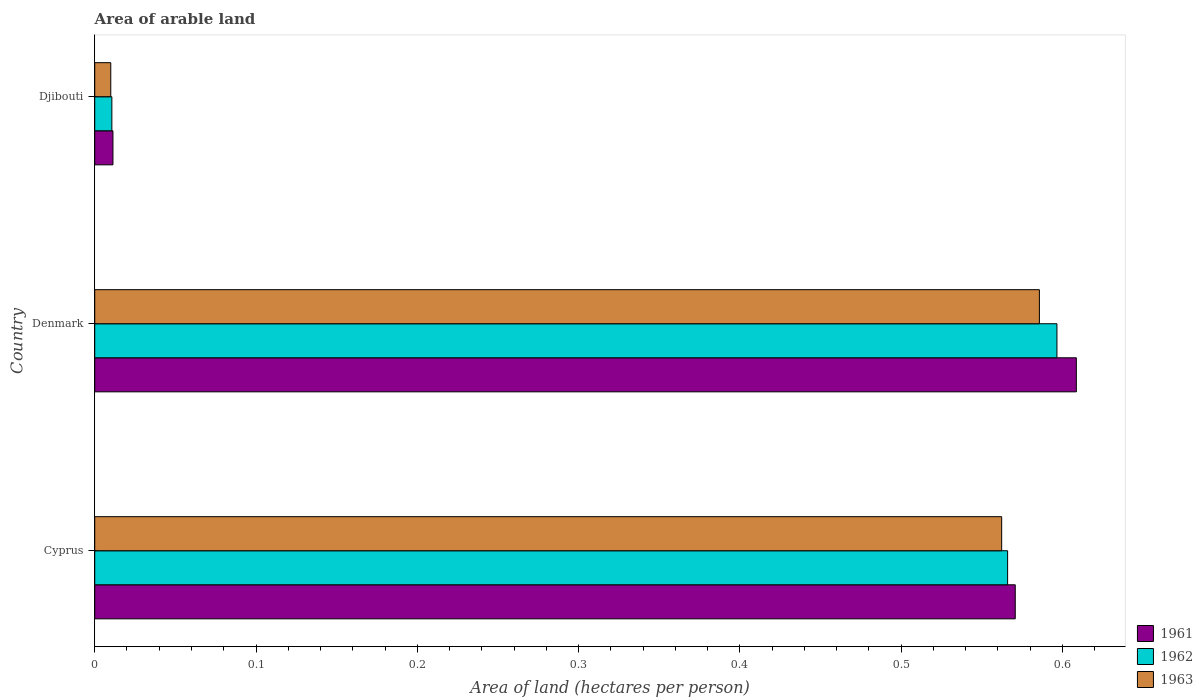How many groups of bars are there?
Provide a short and direct response. 3. Are the number of bars per tick equal to the number of legend labels?
Offer a very short reply. Yes. How many bars are there on the 2nd tick from the bottom?
Make the answer very short. 3. What is the label of the 2nd group of bars from the top?
Keep it short and to the point. Denmark. In how many cases, is the number of bars for a given country not equal to the number of legend labels?
Offer a very short reply. 0. What is the total arable land in 1961 in Denmark?
Your answer should be very brief. 0.61. Across all countries, what is the maximum total arable land in 1962?
Offer a terse response. 0.6. Across all countries, what is the minimum total arable land in 1963?
Your response must be concise. 0.01. In which country was the total arable land in 1963 minimum?
Make the answer very short. Djibouti. What is the total total arable land in 1962 in the graph?
Your answer should be compact. 1.17. What is the difference between the total arable land in 1961 in Denmark and that in Djibouti?
Make the answer very short. 0.6. What is the difference between the total arable land in 1962 in Denmark and the total arable land in 1961 in Cyprus?
Offer a very short reply. 0.03. What is the average total arable land in 1961 per country?
Your answer should be very brief. 0.4. What is the difference between the total arable land in 1961 and total arable land in 1962 in Denmark?
Provide a short and direct response. 0.01. What is the ratio of the total arable land in 1962 in Cyprus to that in Djibouti?
Your answer should be compact. 53.32. Is the difference between the total arable land in 1961 in Cyprus and Denmark greater than the difference between the total arable land in 1962 in Cyprus and Denmark?
Give a very brief answer. No. What is the difference between the highest and the second highest total arable land in 1963?
Your response must be concise. 0.02. What is the difference between the highest and the lowest total arable land in 1963?
Offer a very short reply. 0.58. Is the sum of the total arable land in 1963 in Cyprus and Djibouti greater than the maximum total arable land in 1961 across all countries?
Provide a short and direct response. No. Is it the case that in every country, the sum of the total arable land in 1962 and total arable land in 1963 is greater than the total arable land in 1961?
Offer a terse response. Yes. Are all the bars in the graph horizontal?
Provide a short and direct response. Yes. Does the graph contain any zero values?
Give a very brief answer. No. Does the graph contain grids?
Make the answer very short. No. Where does the legend appear in the graph?
Make the answer very short. Bottom right. How many legend labels are there?
Offer a terse response. 3. How are the legend labels stacked?
Provide a succinct answer. Vertical. What is the title of the graph?
Provide a succinct answer. Area of arable land. What is the label or title of the X-axis?
Offer a terse response. Area of land (hectares per person). What is the Area of land (hectares per person) of 1961 in Cyprus?
Ensure brevity in your answer.  0.57. What is the Area of land (hectares per person) in 1962 in Cyprus?
Offer a terse response. 0.57. What is the Area of land (hectares per person) of 1963 in Cyprus?
Ensure brevity in your answer.  0.56. What is the Area of land (hectares per person) of 1961 in Denmark?
Make the answer very short. 0.61. What is the Area of land (hectares per person) in 1962 in Denmark?
Offer a very short reply. 0.6. What is the Area of land (hectares per person) in 1963 in Denmark?
Offer a terse response. 0.59. What is the Area of land (hectares per person) of 1961 in Djibouti?
Ensure brevity in your answer.  0.01. What is the Area of land (hectares per person) of 1962 in Djibouti?
Make the answer very short. 0.01. What is the Area of land (hectares per person) of 1963 in Djibouti?
Make the answer very short. 0.01. Across all countries, what is the maximum Area of land (hectares per person) in 1961?
Make the answer very short. 0.61. Across all countries, what is the maximum Area of land (hectares per person) in 1962?
Your answer should be compact. 0.6. Across all countries, what is the maximum Area of land (hectares per person) of 1963?
Provide a short and direct response. 0.59. Across all countries, what is the minimum Area of land (hectares per person) in 1961?
Offer a very short reply. 0.01. Across all countries, what is the minimum Area of land (hectares per person) in 1962?
Keep it short and to the point. 0.01. Across all countries, what is the minimum Area of land (hectares per person) of 1963?
Your response must be concise. 0.01. What is the total Area of land (hectares per person) in 1961 in the graph?
Your answer should be compact. 1.19. What is the total Area of land (hectares per person) in 1962 in the graph?
Your response must be concise. 1.17. What is the total Area of land (hectares per person) in 1963 in the graph?
Your answer should be compact. 1.16. What is the difference between the Area of land (hectares per person) of 1961 in Cyprus and that in Denmark?
Make the answer very short. -0.04. What is the difference between the Area of land (hectares per person) of 1962 in Cyprus and that in Denmark?
Keep it short and to the point. -0.03. What is the difference between the Area of land (hectares per person) of 1963 in Cyprus and that in Denmark?
Give a very brief answer. -0.02. What is the difference between the Area of land (hectares per person) of 1961 in Cyprus and that in Djibouti?
Provide a succinct answer. 0.56. What is the difference between the Area of land (hectares per person) in 1962 in Cyprus and that in Djibouti?
Offer a terse response. 0.56. What is the difference between the Area of land (hectares per person) in 1963 in Cyprus and that in Djibouti?
Your response must be concise. 0.55. What is the difference between the Area of land (hectares per person) in 1961 in Denmark and that in Djibouti?
Provide a succinct answer. 0.6. What is the difference between the Area of land (hectares per person) of 1962 in Denmark and that in Djibouti?
Ensure brevity in your answer.  0.59. What is the difference between the Area of land (hectares per person) of 1963 in Denmark and that in Djibouti?
Provide a short and direct response. 0.58. What is the difference between the Area of land (hectares per person) in 1961 in Cyprus and the Area of land (hectares per person) in 1962 in Denmark?
Provide a short and direct response. -0.03. What is the difference between the Area of land (hectares per person) of 1961 in Cyprus and the Area of land (hectares per person) of 1963 in Denmark?
Your response must be concise. -0.01. What is the difference between the Area of land (hectares per person) in 1962 in Cyprus and the Area of land (hectares per person) in 1963 in Denmark?
Ensure brevity in your answer.  -0.02. What is the difference between the Area of land (hectares per person) in 1961 in Cyprus and the Area of land (hectares per person) in 1962 in Djibouti?
Your response must be concise. 0.56. What is the difference between the Area of land (hectares per person) in 1961 in Cyprus and the Area of land (hectares per person) in 1963 in Djibouti?
Make the answer very short. 0.56. What is the difference between the Area of land (hectares per person) in 1962 in Cyprus and the Area of land (hectares per person) in 1963 in Djibouti?
Give a very brief answer. 0.56. What is the difference between the Area of land (hectares per person) in 1961 in Denmark and the Area of land (hectares per person) in 1962 in Djibouti?
Ensure brevity in your answer.  0.6. What is the difference between the Area of land (hectares per person) of 1961 in Denmark and the Area of land (hectares per person) of 1963 in Djibouti?
Your answer should be compact. 0.6. What is the difference between the Area of land (hectares per person) of 1962 in Denmark and the Area of land (hectares per person) of 1963 in Djibouti?
Keep it short and to the point. 0.59. What is the average Area of land (hectares per person) of 1961 per country?
Offer a terse response. 0.4. What is the average Area of land (hectares per person) in 1962 per country?
Your answer should be very brief. 0.39. What is the average Area of land (hectares per person) of 1963 per country?
Provide a short and direct response. 0.39. What is the difference between the Area of land (hectares per person) in 1961 and Area of land (hectares per person) in 1962 in Cyprus?
Your answer should be very brief. 0. What is the difference between the Area of land (hectares per person) of 1961 and Area of land (hectares per person) of 1963 in Cyprus?
Ensure brevity in your answer.  0.01. What is the difference between the Area of land (hectares per person) in 1962 and Area of land (hectares per person) in 1963 in Cyprus?
Make the answer very short. 0. What is the difference between the Area of land (hectares per person) in 1961 and Area of land (hectares per person) in 1962 in Denmark?
Provide a short and direct response. 0.01. What is the difference between the Area of land (hectares per person) in 1961 and Area of land (hectares per person) in 1963 in Denmark?
Keep it short and to the point. 0.02. What is the difference between the Area of land (hectares per person) in 1962 and Area of land (hectares per person) in 1963 in Denmark?
Provide a succinct answer. 0.01. What is the difference between the Area of land (hectares per person) of 1961 and Area of land (hectares per person) of 1962 in Djibouti?
Ensure brevity in your answer.  0. What is the difference between the Area of land (hectares per person) of 1961 and Area of land (hectares per person) of 1963 in Djibouti?
Give a very brief answer. 0. What is the difference between the Area of land (hectares per person) of 1962 and Area of land (hectares per person) of 1963 in Djibouti?
Provide a short and direct response. 0. What is the ratio of the Area of land (hectares per person) in 1961 in Cyprus to that in Denmark?
Your response must be concise. 0.94. What is the ratio of the Area of land (hectares per person) of 1962 in Cyprus to that in Denmark?
Your answer should be compact. 0.95. What is the ratio of the Area of land (hectares per person) in 1963 in Cyprus to that in Denmark?
Offer a terse response. 0.96. What is the ratio of the Area of land (hectares per person) in 1961 in Cyprus to that in Djibouti?
Provide a succinct answer. 50.51. What is the ratio of the Area of land (hectares per person) of 1962 in Cyprus to that in Djibouti?
Keep it short and to the point. 53.32. What is the ratio of the Area of land (hectares per person) in 1963 in Cyprus to that in Djibouti?
Your answer should be compact. 56.59. What is the ratio of the Area of land (hectares per person) of 1961 in Denmark to that in Djibouti?
Make the answer very short. 53.87. What is the ratio of the Area of land (hectares per person) in 1962 in Denmark to that in Djibouti?
Ensure brevity in your answer.  56.2. What is the ratio of the Area of land (hectares per person) in 1963 in Denmark to that in Djibouti?
Your response must be concise. 58.94. What is the difference between the highest and the second highest Area of land (hectares per person) of 1961?
Provide a short and direct response. 0.04. What is the difference between the highest and the second highest Area of land (hectares per person) in 1962?
Provide a succinct answer. 0.03. What is the difference between the highest and the second highest Area of land (hectares per person) of 1963?
Give a very brief answer. 0.02. What is the difference between the highest and the lowest Area of land (hectares per person) in 1961?
Provide a short and direct response. 0.6. What is the difference between the highest and the lowest Area of land (hectares per person) in 1962?
Give a very brief answer. 0.59. What is the difference between the highest and the lowest Area of land (hectares per person) in 1963?
Provide a succinct answer. 0.58. 